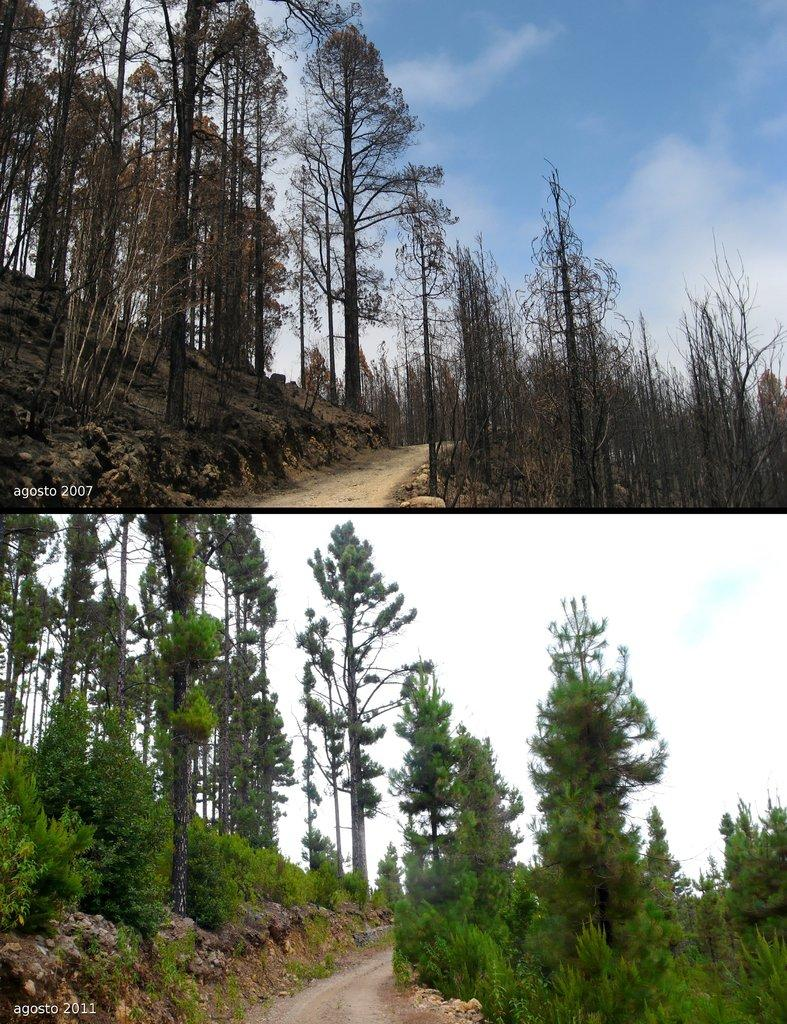What type of pictures are present in the image? The image contains collage pictures. What elements can be found in the collage pictures? The collage pictures include trees, roads, sky, and clouds. What type of surprise can be seen in the collage pictures? There is no surprise present in the collage pictures; they are composed of various elements like trees, roads, sky, and clouds. 